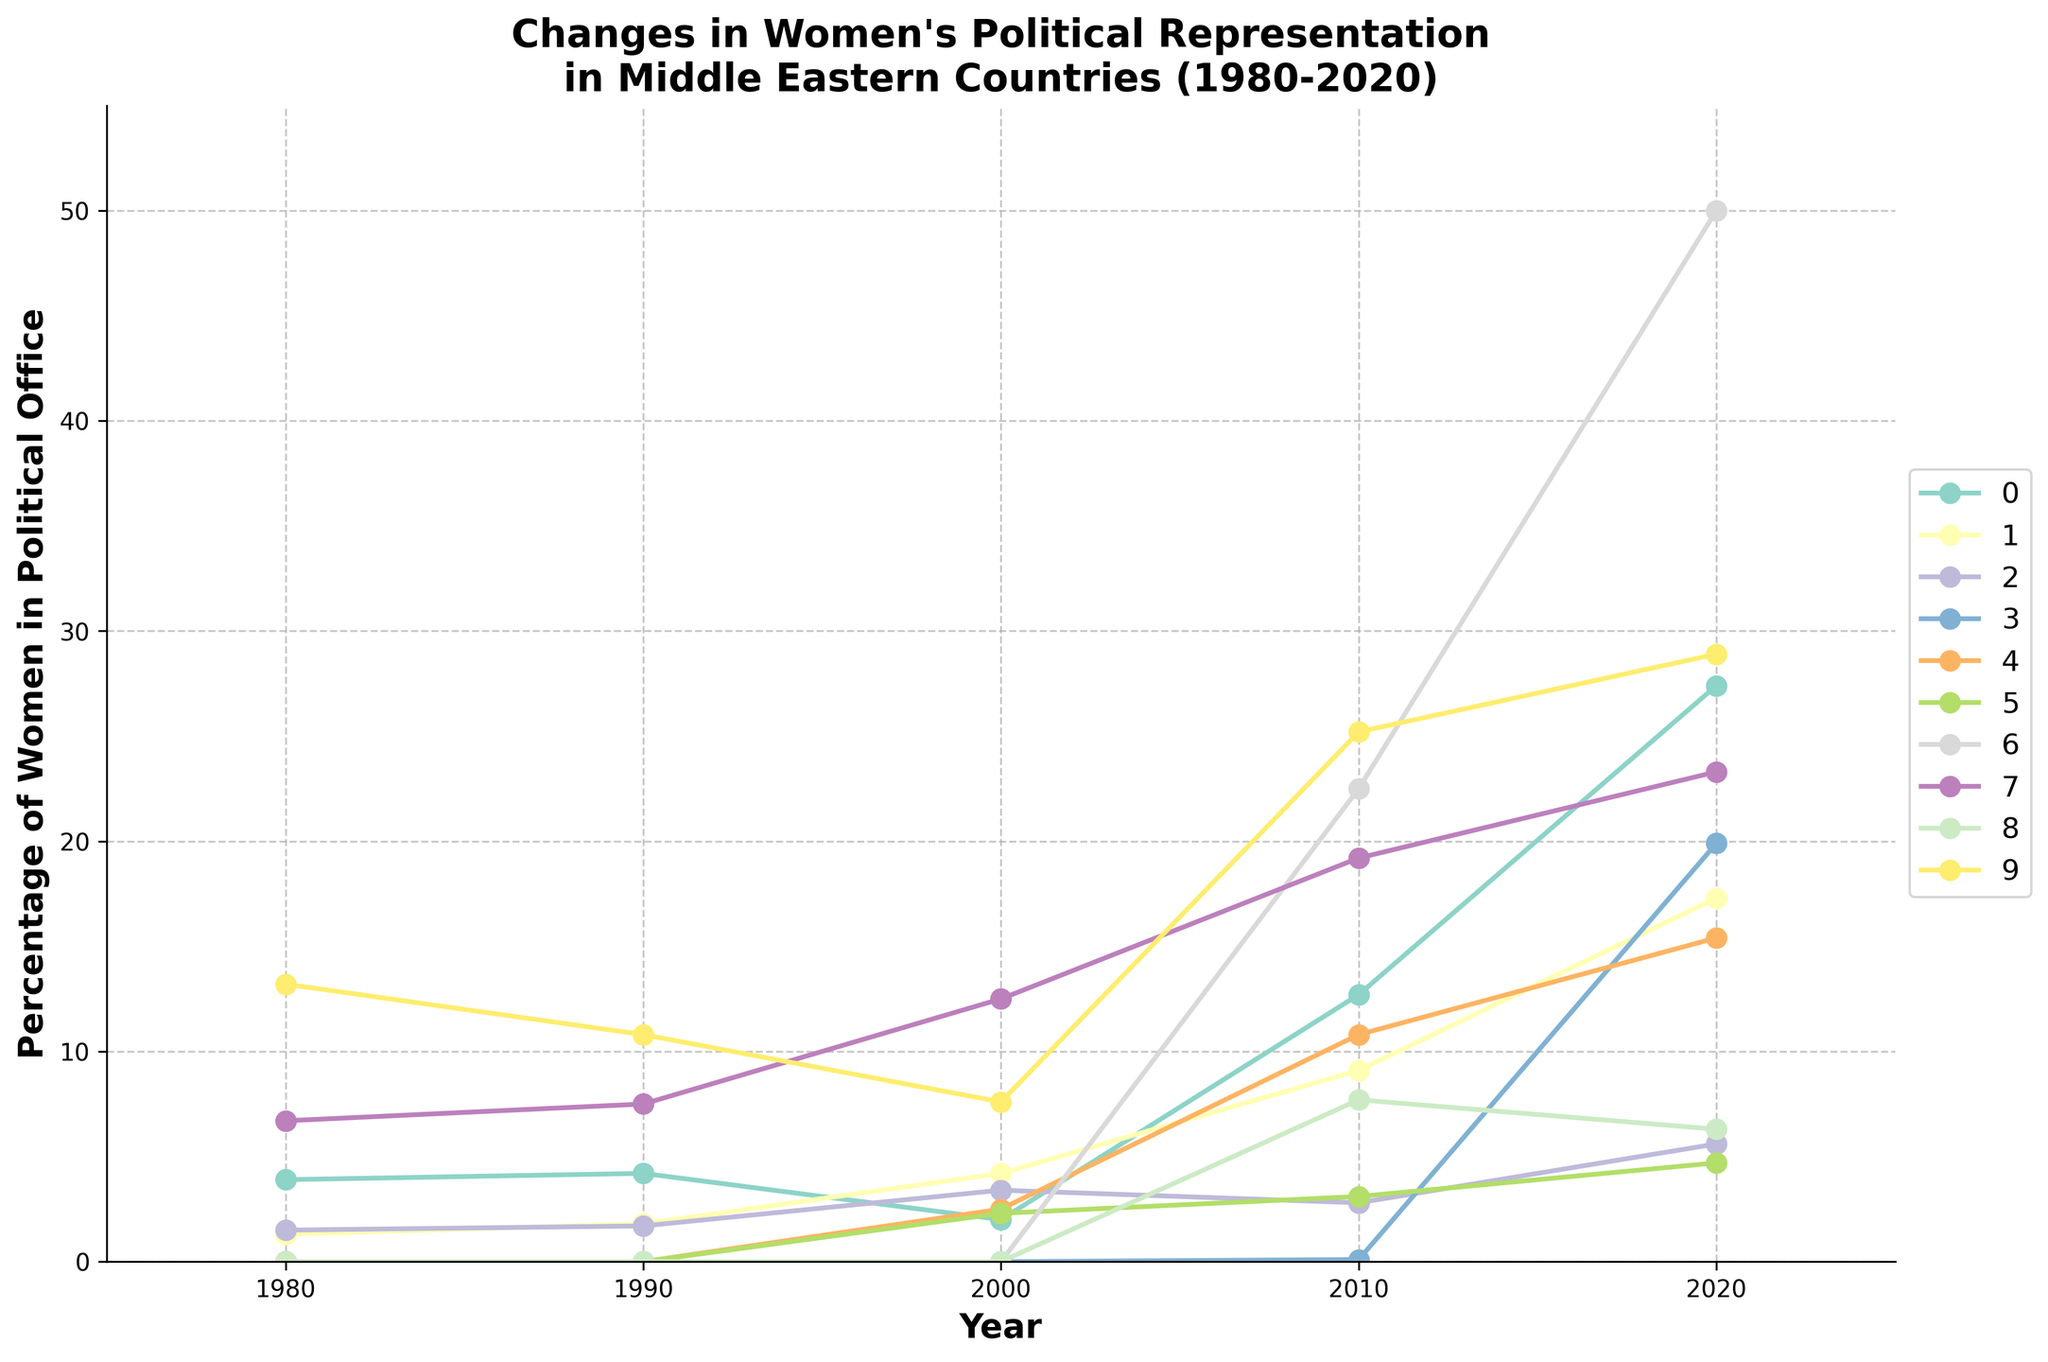What is the trend for women holding political office in Turkey from 1980 to 2020? From the figure, we see the markers and lines for Turkey rising over the years, showing increasing percentages: 1.3% in 1980, 1.8% in 1990, 4.2% in 2000, 9.1% in 2010, and peaking at 17.3% in 2020. Hence, the trend is upward.
Answer: Increasing Which country had the most substantial increase in the percentage of women in political office between 1980 and 2020? To find this, we should compare the percentages of each country in 1980 and 2020 and see which had the highest increase. The United Arab Emirates (UAE) exhibits a striking increase from 0% in 1980 to 50% in 2020.
Answer: United Arab Emirates Looking at the data for Lebanon, did the percentage of women in political office ever decrease between the recorded years? Observing the curve for Lebanon, the percentage of women holding political office has only increased over the years: 0% in 1980 and 1990, 2.3% in 2000, 3.1% in 2010, and 4.7% in 2020.
Answer: No Which country has the highest percentage of women in political office in 2020? From the rightmost points for each country on the graph, the UAE stands out with 50%, which is the highest in 2020.
Answer: United Arab Emirates How does the percentage of women in political office in Iraq in 2020 compare to that in Israel? By looking at the 2020 data points for Iraq and Israel, Iraq has a slightly higher percentage at 28.9%, compared to Israel's 23.3%.
Answer: Iraq has more Calculate the average percentage of women in political office in Jordan over the recorded years. Adding up the percentages for Jordan: 0% (1980), 0% (1990), 2.5% (2000), 10.8% (2010), and 15.4% (2020), and dividing by 5 gives: (0 + 0 + 2.5 + 10.8 + 15.4) / 5 = 28.7 / 5 = 5.74%.
Answer: 5.74% Which country had no women in political office until 2000? The lines for Saudi Arabia, UAE, and Kuwait all remain at 0 until 2000.
Answer: Saudi Arabia, UAE, Kuwait Compare the trends for Iran and Kuwait from 1980 to 2020. Iran shows a slow increase: 1.5% (1980) to 5.6% (2020). Kuwait, starting at 0% until 2000, rises to 6.3% in 2020. Iran's increase is steadier but less dramatic compared to Kuwait’s late but sharp rise.
Answer: Iran is steadier; Kuwait is sharper later What was the approximate percentage of women holding political office in Egypt in 2000? Referring to the point for Egypt in the year 2000 on the graph, the value is around 2%.
Answer: 2% Which country had the lowest increase in the percentage of women in political office from 1980 to 2020? Calculating the difference for each country: Lebanon increased from 0% to 4.7%, which is the lowest increase when compared to other countries.
Answer: Lebanon 